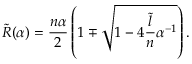Convert formula to latex. <formula><loc_0><loc_0><loc_500><loc_500>\tilde { R } ( \alpha ) = \frac { n \alpha } { 2 } \left ( 1 \mp \sqrt { 1 - 4 \frac { \tilde { l } } { n } \alpha ^ { - 1 } } \right ) .</formula> 